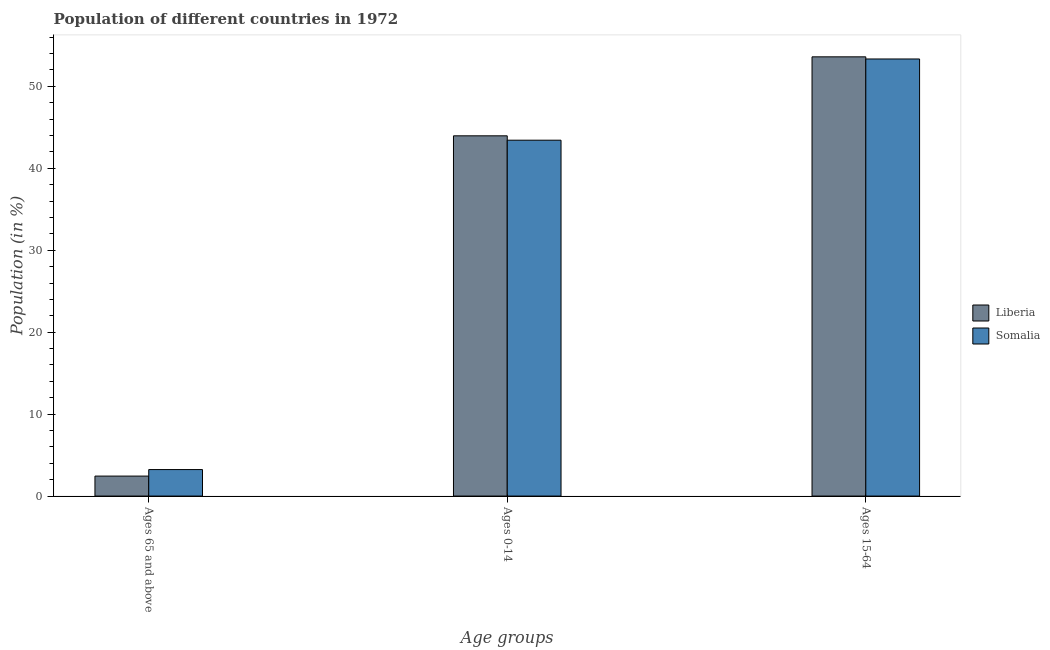How many different coloured bars are there?
Ensure brevity in your answer.  2. Are the number of bars per tick equal to the number of legend labels?
Keep it short and to the point. Yes. Are the number of bars on each tick of the X-axis equal?
Provide a succinct answer. Yes. How many bars are there on the 2nd tick from the right?
Ensure brevity in your answer.  2. What is the label of the 2nd group of bars from the left?
Your response must be concise. Ages 0-14. What is the percentage of population within the age-group of 65 and above in Somalia?
Your answer should be compact. 3.23. Across all countries, what is the maximum percentage of population within the age-group 0-14?
Make the answer very short. 43.96. Across all countries, what is the minimum percentage of population within the age-group of 65 and above?
Provide a succinct answer. 2.44. In which country was the percentage of population within the age-group 15-64 maximum?
Your answer should be very brief. Liberia. In which country was the percentage of population within the age-group 0-14 minimum?
Provide a succinct answer. Somalia. What is the total percentage of population within the age-group 15-64 in the graph?
Provide a short and direct response. 106.94. What is the difference between the percentage of population within the age-group 0-14 in Liberia and that in Somalia?
Give a very brief answer. 0.53. What is the difference between the percentage of population within the age-group 15-64 in Liberia and the percentage of population within the age-group of 65 and above in Somalia?
Offer a very short reply. 50.37. What is the average percentage of population within the age-group 15-64 per country?
Your answer should be very brief. 53.47. What is the difference between the percentage of population within the age-group 15-64 and percentage of population within the age-group 0-14 in Liberia?
Your answer should be compact. 9.64. In how many countries, is the percentage of population within the age-group of 65 and above greater than 4 %?
Your answer should be compact. 0. What is the ratio of the percentage of population within the age-group 15-64 in Somalia to that in Liberia?
Keep it short and to the point. 1. Is the difference between the percentage of population within the age-group 0-14 in Liberia and Somalia greater than the difference between the percentage of population within the age-group of 65 and above in Liberia and Somalia?
Give a very brief answer. Yes. What is the difference between the highest and the second highest percentage of population within the age-group of 65 and above?
Provide a succinct answer. 0.8. What is the difference between the highest and the lowest percentage of population within the age-group of 65 and above?
Your response must be concise. 0.8. In how many countries, is the percentage of population within the age-group of 65 and above greater than the average percentage of population within the age-group of 65 and above taken over all countries?
Make the answer very short. 1. Is the sum of the percentage of population within the age-group 15-64 in Somalia and Liberia greater than the maximum percentage of population within the age-group of 65 and above across all countries?
Give a very brief answer. Yes. What does the 1st bar from the left in Ages 65 and above represents?
Give a very brief answer. Liberia. What does the 1st bar from the right in Ages 0-14 represents?
Give a very brief answer. Somalia. Is it the case that in every country, the sum of the percentage of population within the age-group of 65 and above and percentage of population within the age-group 0-14 is greater than the percentage of population within the age-group 15-64?
Make the answer very short. No. How many bars are there?
Your answer should be compact. 6. Are all the bars in the graph horizontal?
Provide a succinct answer. No. How many countries are there in the graph?
Offer a very short reply. 2. What is the difference between two consecutive major ticks on the Y-axis?
Offer a very short reply. 10. Are the values on the major ticks of Y-axis written in scientific E-notation?
Provide a short and direct response. No. Does the graph contain any zero values?
Give a very brief answer. No. Does the graph contain grids?
Provide a short and direct response. No. How many legend labels are there?
Give a very brief answer. 2. What is the title of the graph?
Your answer should be very brief. Population of different countries in 1972. What is the label or title of the X-axis?
Keep it short and to the point. Age groups. What is the label or title of the Y-axis?
Offer a terse response. Population (in %). What is the Population (in %) of Liberia in Ages 65 and above?
Keep it short and to the point. 2.44. What is the Population (in %) of Somalia in Ages 65 and above?
Ensure brevity in your answer.  3.23. What is the Population (in %) of Liberia in Ages 0-14?
Provide a short and direct response. 43.96. What is the Population (in %) of Somalia in Ages 0-14?
Offer a very short reply. 43.43. What is the Population (in %) of Liberia in Ages 15-64?
Offer a very short reply. 53.6. What is the Population (in %) in Somalia in Ages 15-64?
Keep it short and to the point. 53.34. Across all Age groups, what is the maximum Population (in %) of Liberia?
Your response must be concise. 53.6. Across all Age groups, what is the maximum Population (in %) in Somalia?
Keep it short and to the point. 53.34. Across all Age groups, what is the minimum Population (in %) of Liberia?
Keep it short and to the point. 2.44. Across all Age groups, what is the minimum Population (in %) in Somalia?
Give a very brief answer. 3.23. What is the total Population (in %) in Liberia in the graph?
Offer a terse response. 100. What is the total Population (in %) in Somalia in the graph?
Your answer should be compact. 100. What is the difference between the Population (in %) in Liberia in Ages 65 and above and that in Ages 0-14?
Offer a very short reply. -41.52. What is the difference between the Population (in %) in Somalia in Ages 65 and above and that in Ages 0-14?
Offer a terse response. -40.19. What is the difference between the Population (in %) of Liberia in Ages 65 and above and that in Ages 15-64?
Ensure brevity in your answer.  -51.16. What is the difference between the Population (in %) in Somalia in Ages 65 and above and that in Ages 15-64?
Your answer should be very brief. -50.11. What is the difference between the Population (in %) of Liberia in Ages 0-14 and that in Ages 15-64?
Ensure brevity in your answer.  -9.64. What is the difference between the Population (in %) of Somalia in Ages 0-14 and that in Ages 15-64?
Your response must be concise. -9.91. What is the difference between the Population (in %) in Liberia in Ages 65 and above and the Population (in %) in Somalia in Ages 0-14?
Ensure brevity in your answer.  -40.99. What is the difference between the Population (in %) in Liberia in Ages 65 and above and the Population (in %) in Somalia in Ages 15-64?
Ensure brevity in your answer.  -50.9. What is the difference between the Population (in %) of Liberia in Ages 0-14 and the Population (in %) of Somalia in Ages 15-64?
Provide a succinct answer. -9.38. What is the average Population (in %) in Liberia per Age groups?
Ensure brevity in your answer.  33.33. What is the average Population (in %) of Somalia per Age groups?
Offer a terse response. 33.33. What is the difference between the Population (in %) in Liberia and Population (in %) in Somalia in Ages 65 and above?
Offer a terse response. -0.8. What is the difference between the Population (in %) in Liberia and Population (in %) in Somalia in Ages 0-14?
Offer a very short reply. 0.53. What is the difference between the Population (in %) of Liberia and Population (in %) of Somalia in Ages 15-64?
Your answer should be compact. 0.26. What is the ratio of the Population (in %) in Liberia in Ages 65 and above to that in Ages 0-14?
Your answer should be compact. 0.06. What is the ratio of the Population (in %) of Somalia in Ages 65 and above to that in Ages 0-14?
Your answer should be compact. 0.07. What is the ratio of the Population (in %) in Liberia in Ages 65 and above to that in Ages 15-64?
Give a very brief answer. 0.05. What is the ratio of the Population (in %) in Somalia in Ages 65 and above to that in Ages 15-64?
Ensure brevity in your answer.  0.06. What is the ratio of the Population (in %) of Liberia in Ages 0-14 to that in Ages 15-64?
Ensure brevity in your answer.  0.82. What is the ratio of the Population (in %) of Somalia in Ages 0-14 to that in Ages 15-64?
Make the answer very short. 0.81. What is the difference between the highest and the second highest Population (in %) of Liberia?
Ensure brevity in your answer.  9.64. What is the difference between the highest and the second highest Population (in %) in Somalia?
Give a very brief answer. 9.91. What is the difference between the highest and the lowest Population (in %) of Liberia?
Your response must be concise. 51.16. What is the difference between the highest and the lowest Population (in %) of Somalia?
Provide a succinct answer. 50.11. 